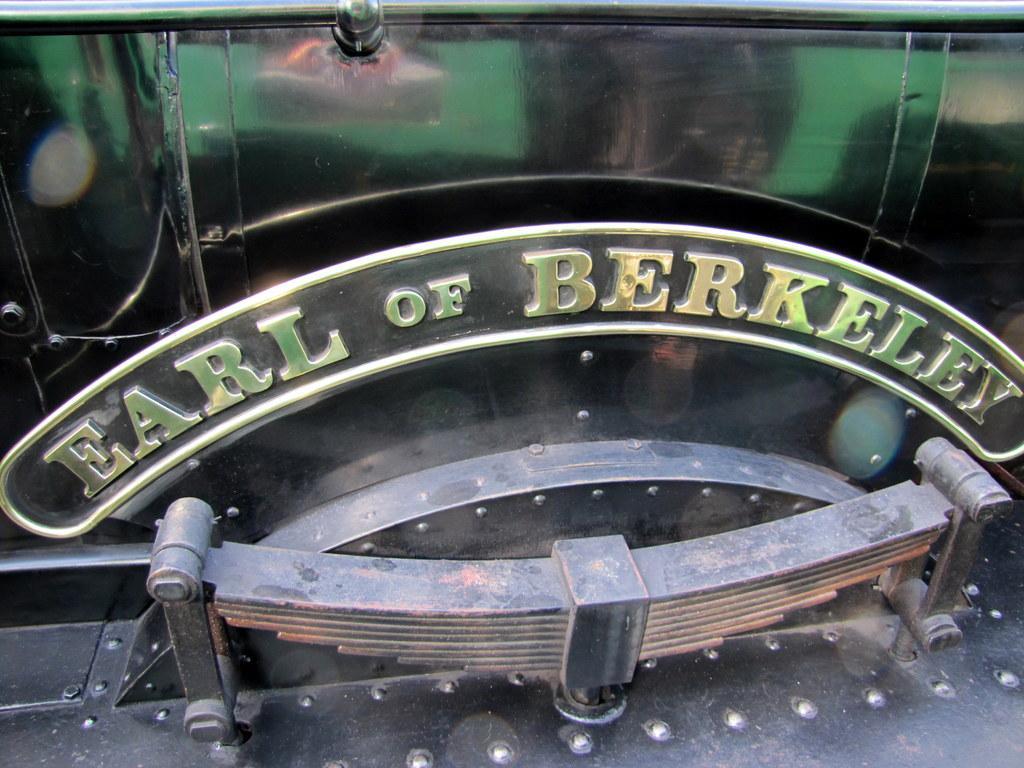How would you summarize this image in a sentence or two? In this image we can see a train name plate on it. 